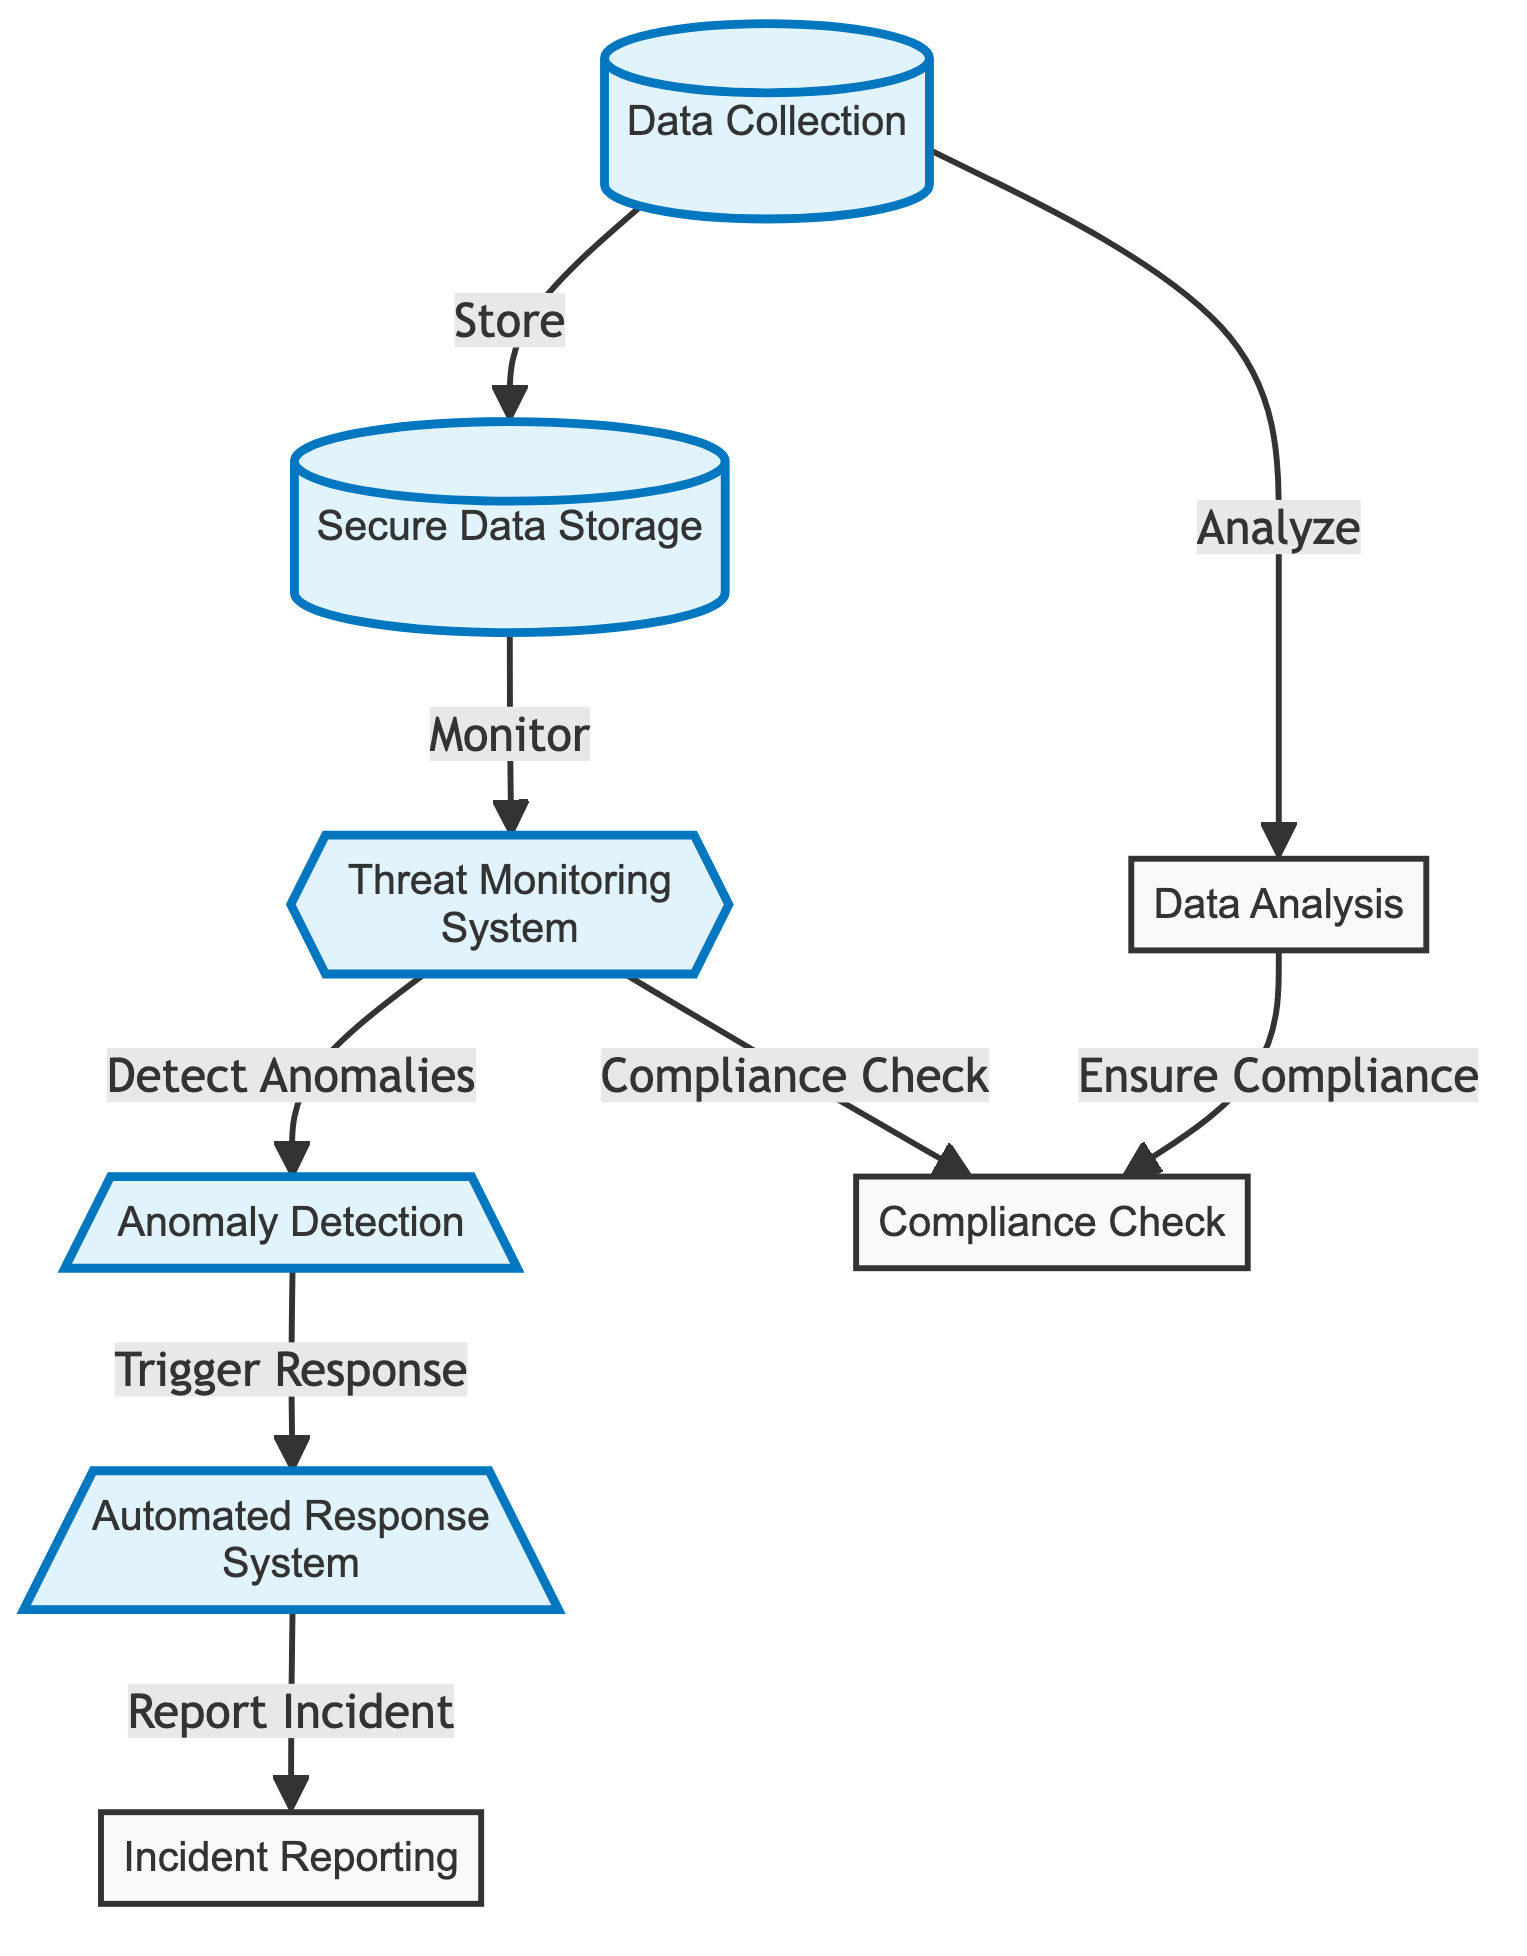What is the first step in the process? The first step is “Data Collection,” which is the initial action taken before any subsequent processes can occur. It is the starting point of the flow depicted in the diagram.
Answer: Data Collection How many nodes are highlighted in the diagram? There are six nodes highlighted, which are “Data Collection,” “Secure Data Storage,” “Threat Monitoring System,” “Anomaly Detection,” “Automated Response System,” and “Incident Reporting.”
Answer: Six Which node is responsible for monitoring the data? The node responsible for monitoring the data is “Threat Monitoring System.” It is directly linked to the “Secure Data Storage” node, indicating its monitoring function over that stored data.
Answer: Threat Monitoring System What action does the “Anomaly Detection” node trigger? The “Anomaly Detection” node triggers the “Automated Response System.” This indicates that when anomalies are detected, the system responds automatically to address the issue.
Answer: Automated Response System How does the “Data Analysis” node relate to compliance? The “Data Analysis” node relates to compliance by ensuring compliance after analyzing the data, showing a connection and responsibility involving data integrity and regulatory adherence.
Answer: Ensure Compliance What is the outcome of detecting anomalies in the threat monitoring system? The outcome of detecting anomalies in the threat monitoring system is the triggering of the automated response system, which is a direct action taken based on the anomaly detection.
Answer: Trigger Response Which node checks for compliance alongside threat monitoring? The “Compliance Check” node checks for compliance alongside the “Threat Monitoring System.” This suggests that compliance is continuously assessed as part of the threat monitoring process.
Answer: Compliance Check 